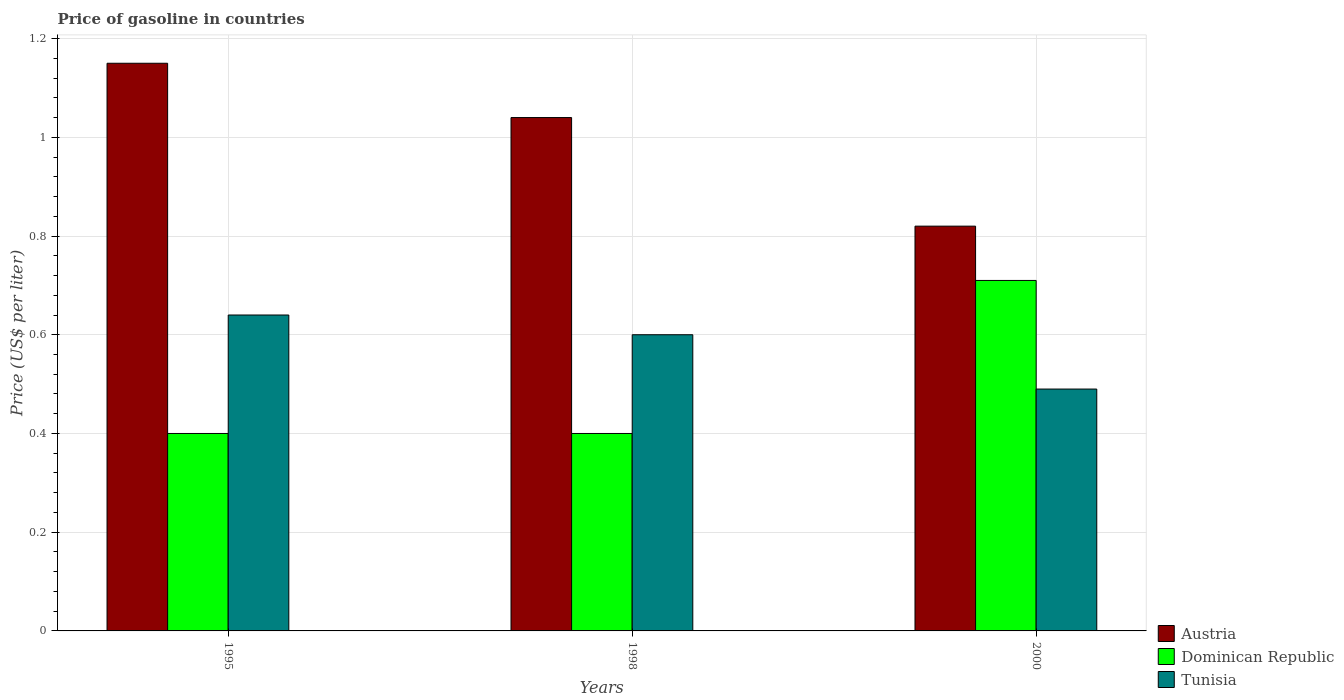How many groups of bars are there?
Ensure brevity in your answer.  3. Are the number of bars on each tick of the X-axis equal?
Keep it short and to the point. Yes. How many bars are there on the 2nd tick from the left?
Offer a very short reply. 3. How many bars are there on the 3rd tick from the right?
Make the answer very short. 3. What is the label of the 3rd group of bars from the left?
Give a very brief answer. 2000. In how many cases, is the number of bars for a given year not equal to the number of legend labels?
Your answer should be very brief. 0. What is the price of gasoline in Dominican Republic in 1998?
Give a very brief answer. 0.4. Across all years, what is the maximum price of gasoline in Tunisia?
Offer a terse response. 0.64. Across all years, what is the minimum price of gasoline in Dominican Republic?
Ensure brevity in your answer.  0.4. In which year was the price of gasoline in Austria maximum?
Ensure brevity in your answer.  1995. What is the total price of gasoline in Tunisia in the graph?
Offer a terse response. 1.73. What is the difference between the price of gasoline in Dominican Republic in 1995 and that in 1998?
Your answer should be very brief. 0. What is the difference between the price of gasoline in Dominican Republic in 1998 and the price of gasoline in Austria in 1995?
Your answer should be compact. -0.75. What is the average price of gasoline in Austria per year?
Keep it short and to the point. 1. In the year 2000, what is the difference between the price of gasoline in Tunisia and price of gasoline in Dominican Republic?
Make the answer very short. -0.22. In how many years, is the price of gasoline in Dominican Republic greater than 0.32 US$?
Offer a very short reply. 3. What is the ratio of the price of gasoline in Austria in 1995 to that in 1998?
Your response must be concise. 1.11. Is the price of gasoline in Tunisia in 1995 less than that in 1998?
Your answer should be compact. No. Is the difference between the price of gasoline in Tunisia in 1995 and 2000 greater than the difference between the price of gasoline in Dominican Republic in 1995 and 2000?
Ensure brevity in your answer.  Yes. What is the difference between the highest and the second highest price of gasoline in Tunisia?
Provide a short and direct response. 0.04. What is the difference between the highest and the lowest price of gasoline in Austria?
Offer a terse response. 0.33. Is the sum of the price of gasoline in Dominican Republic in 1995 and 1998 greater than the maximum price of gasoline in Tunisia across all years?
Your answer should be very brief. Yes. What does the 2nd bar from the left in 1998 represents?
Make the answer very short. Dominican Republic. What does the 3rd bar from the right in 2000 represents?
Your answer should be compact. Austria. Is it the case that in every year, the sum of the price of gasoline in Dominican Republic and price of gasoline in Tunisia is greater than the price of gasoline in Austria?
Make the answer very short. No. How many bars are there?
Offer a very short reply. 9. How many years are there in the graph?
Ensure brevity in your answer.  3. Are the values on the major ticks of Y-axis written in scientific E-notation?
Offer a very short reply. No. Does the graph contain any zero values?
Your answer should be compact. No. Does the graph contain grids?
Your response must be concise. Yes. How many legend labels are there?
Your response must be concise. 3. How are the legend labels stacked?
Ensure brevity in your answer.  Vertical. What is the title of the graph?
Offer a very short reply. Price of gasoline in countries. Does "Micronesia" appear as one of the legend labels in the graph?
Your response must be concise. No. What is the label or title of the X-axis?
Provide a short and direct response. Years. What is the label or title of the Y-axis?
Ensure brevity in your answer.  Price (US$ per liter). What is the Price (US$ per liter) in Austria in 1995?
Offer a very short reply. 1.15. What is the Price (US$ per liter) of Dominican Republic in 1995?
Offer a very short reply. 0.4. What is the Price (US$ per liter) of Tunisia in 1995?
Offer a very short reply. 0.64. What is the Price (US$ per liter) in Austria in 1998?
Your response must be concise. 1.04. What is the Price (US$ per liter) in Dominican Republic in 1998?
Your answer should be compact. 0.4. What is the Price (US$ per liter) in Austria in 2000?
Your response must be concise. 0.82. What is the Price (US$ per liter) of Dominican Republic in 2000?
Your answer should be very brief. 0.71. What is the Price (US$ per liter) of Tunisia in 2000?
Make the answer very short. 0.49. Across all years, what is the maximum Price (US$ per liter) in Austria?
Your answer should be very brief. 1.15. Across all years, what is the maximum Price (US$ per liter) of Dominican Republic?
Ensure brevity in your answer.  0.71. Across all years, what is the maximum Price (US$ per liter) in Tunisia?
Make the answer very short. 0.64. Across all years, what is the minimum Price (US$ per liter) of Austria?
Your answer should be compact. 0.82. Across all years, what is the minimum Price (US$ per liter) in Dominican Republic?
Offer a terse response. 0.4. Across all years, what is the minimum Price (US$ per liter) in Tunisia?
Your answer should be compact. 0.49. What is the total Price (US$ per liter) in Austria in the graph?
Offer a terse response. 3.01. What is the total Price (US$ per liter) of Dominican Republic in the graph?
Your answer should be very brief. 1.51. What is the total Price (US$ per liter) in Tunisia in the graph?
Provide a short and direct response. 1.73. What is the difference between the Price (US$ per liter) in Austria in 1995 and that in 1998?
Make the answer very short. 0.11. What is the difference between the Price (US$ per liter) in Dominican Republic in 1995 and that in 1998?
Provide a succinct answer. 0. What is the difference between the Price (US$ per liter) of Tunisia in 1995 and that in 1998?
Your answer should be very brief. 0.04. What is the difference between the Price (US$ per liter) in Austria in 1995 and that in 2000?
Your answer should be very brief. 0.33. What is the difference between the Price (US$ per liter) of Dominican Republic in 1995 and that in 2000?
Your answer should be very brief. -0.31. What is the difference between the Price (US$ per liter) in Tunisia in 1995 and that in 2000?
Keep it short and to the point. 0.15. What is the difference between the Price (US$ per liter) of Austria in 1998 and that in 2000?
Provide a short and direct response. 0.22. What is the difference between the Price (US$ per liter) in Dominican Republic in 1998 and that in 2000?
Your answer should be compact. -0.31. What is the difference between the Price (US$ per liter) in Tunisia in 1998 and that in 2000?
Ensure brevity in your answer.  0.11. What is the difference between the Price (US$ per liter) in Austria in 1995 and the Price (US$ per liter) in Dominican Republic in 1998?
Your answer should be compact. 0.75. What is the difference between the Price (US$ per liter) in Austria in 1995 and the Price (US$ per liter) in Tunisia in 1998?
Offer a terse response. 0.55. What is the difference between the Price (US$ per liter) of Austria in 1995 and the Price (US$ per liter) of Dominican Republic in 2000?
Keep it short and to the point. 0.44. What is the difference between the Price (US$ per liter) of Austria in 1995 and the Price (US$ per liter) of Tunisia in 2000?
Give a very brief answer. 0.66. What is the difference between the Price (US$ per liter) in Dominican Republic in 1995 and the Price (US$ per liter) in Tunisia in 2000?
Give a very brief answer. -0.09. What is the difference between the Price (US$ per liter) in Austria in 1998 and the Price (US$ per liter) in Dominican Republic in 2000?
Your answer should be very brief. 0.33. What is the difference between the Price (US$ per liter) of Austria in 1998 and the Price (US$ per liter) of Tunisia in 2000?
Your answer should be compact. 0.55. What is the difference between the Price (US$ per liter) in Dominican Republic in 1998 and the Price (US$ per liter) in Tunisia in 2000?
Your answer should be compact. -0.09. What is the average Price (US$ per liter) of Dominican Republic per year?
Your answer should be compact. 0.5. What is the average Price (US$ per liter) of Tunisia per year?
Ensure brevity in your answer.  0.58. In the year 1995, what is the difference between the Price (US$ per liter) of Austria and Price (US$ per liter) of Tunisia?
Ensure brevity in your answer.  0.51. In the year 1995, what is the difference between the Price (US$ per liter) in Dominican Republic and Price (US$ per liter) in Tunisia?
Provide a short and direct response. -0.24. In the year 1998, what is the difference between the Price (US$ per liter) of Austria and Price (US$ per liter) of Dominican Republic?
Offer a terse response. 0.64. In the year 1998, what is the difference between the Price (US$ per liter) in Austria and Price (US$ per liter) in Tunisia?
Your response must be concise. 0.44. In the year 1998, what is the difference between the Price (US$ per liter) in Dominican Republic and Price (US$ per liter) in Tunisia?
Make the answer very short. -0.2. In the year 2000, what is the difference between the Price (US$ per liter) of Austria and Price (US$ per liter) of Dominican Republic?
Provide a succinct answer. 0.11. In the year 2000, what is the difference between the Price (US$ per liter) of Austria and Price (US$ per liter) of Tunisia?
Offer a very short reply. 0.33. In the year 2000, what is the difference between the Price (US$ per liter) in Dominican Republic and Price (US$ per liter) in Tunisia?
Offer a very short reply. 0.22. What is the ratio of the Price (US$ per liter) in Austria in 1995 to that in 1998?
Provide a succinct answer. 1.11. What is the ratio of the Price (US$ per liter) of Dominican Republic in 1995 to that in 1998?
Your answer should be very brief. 1. What is the ratio of the Price (US$ per liter) of Tunisia in 1995 to that in 1998?
Keep it short and to the point. 1.07. What is the ratio of the Price (US$ per liter) in Austria in 1995 to that in 2000?
Offer a terse response. 1.4. What is the ratio of the Price (US$ per liter) of Dominican Republic in 1995 to that in 2000?
Your answer should be compact. 0.56. What is the ratio of the Price (US$ per liter) of Tunisia in 1995 to that in 2000?
Provide a short and direct response. 1.31. What is the ratio of the Price (US$ per liter) in Austria in 1998 to that in 2000?
Offer a terse response. 1.27. What is the ratio of the Price (US$ per liter) in Dominican Republic in 1998 to that in 2000?
Keep it short and to the point. 0.56. What is the ratio of the Price (US$ per liter) of Tunisia in 1998 to that in 2000?
Provide a short and direct response. 1.22. What is the difference between the highest and the second highest Price (US$ per liter) of Austria?
Keep it short and to the point. 0.11. What is the difference between the highest and the second highest Price (US$ per liter) in Dominican Republic?
Offer a terse response. 0.31. What is the difference between the highest and the lowest Price (US$ per liter) in Austria?
Offer a very short reply. 0.33. What is the difference between the highest and the lowest Price (US$ per liter) in Dominican Republic?
Make the answer very short. 0.31. What is the difference between the highest and the lowest Price (US$ per liter) in Tunisia?
Provide a succinct answer. 0.15. 